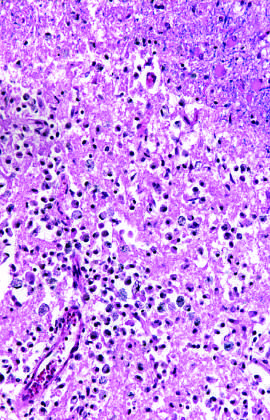what are old intracortical infarcts seen as?
Answer the question using a single word or phrase. Areas of tissue loss and residual gliosis 